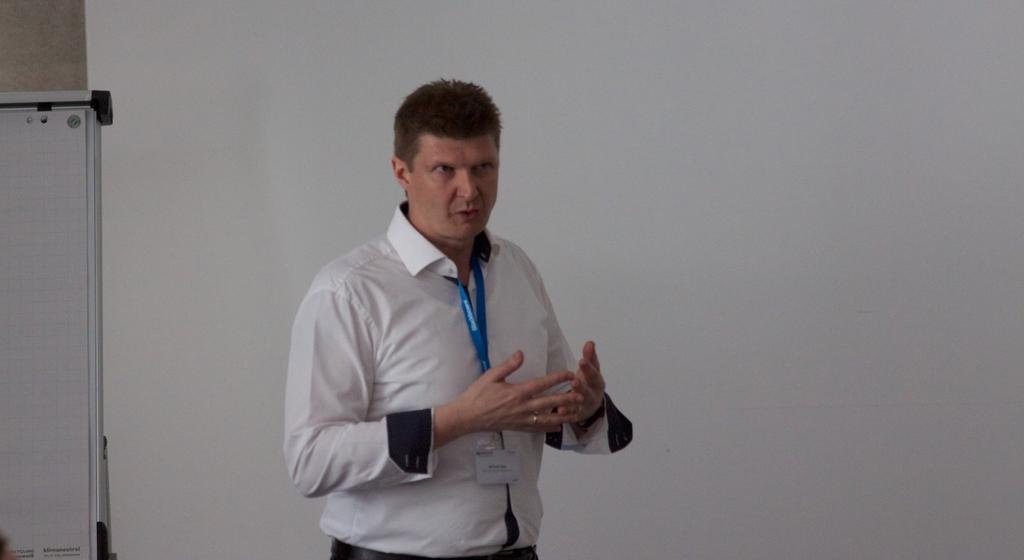Who is present in the image? There is a man in the image. What is the man doing in the image? The man is standing in the image. What is the man wearing that is visible in the image? The man is wearing a tag in the image. What can be seen behind the man in the image? There is a board visible behind the man in the image. What type of crayon is the man using to draw on the board in the image? There is no crayon present in the image, and the man is not drawing on the board. 